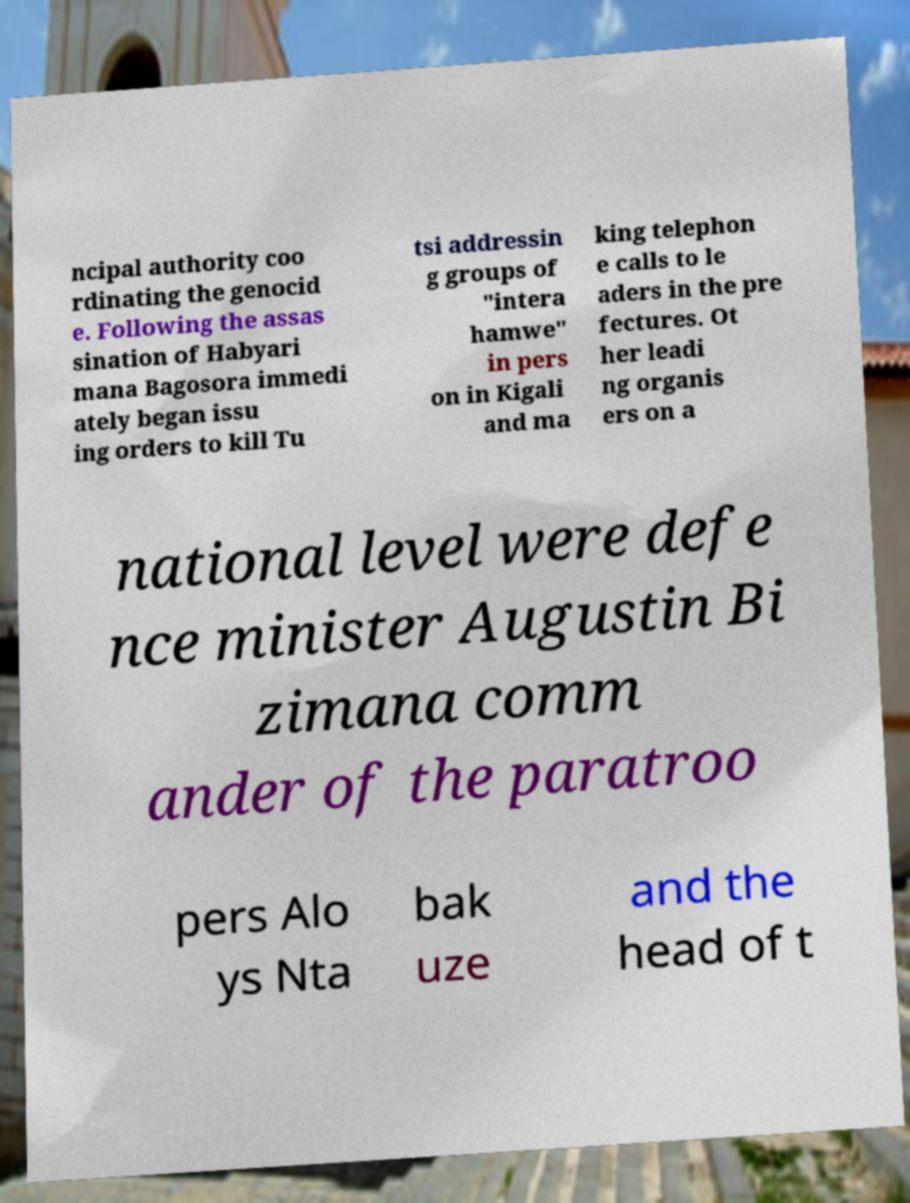There's text embedded in this image that I need extracted. Can you transcribe it verbatim? ncipal authority coo rdinating the genocid e. Following the assas sination of Habyari mana Bagosora immedi ately began issu ing orders to kill Tu tsi addressin g groups of "intera hamwe" in pers on in Kigali and ma king telephon e calls to le aders in the pre fectures. Ot her leadi ng organis ers on a national level were defe nce minister Augustin Bi zimana comm ander of the paratroo pers Alo ys Nta bak uze and the head of t 